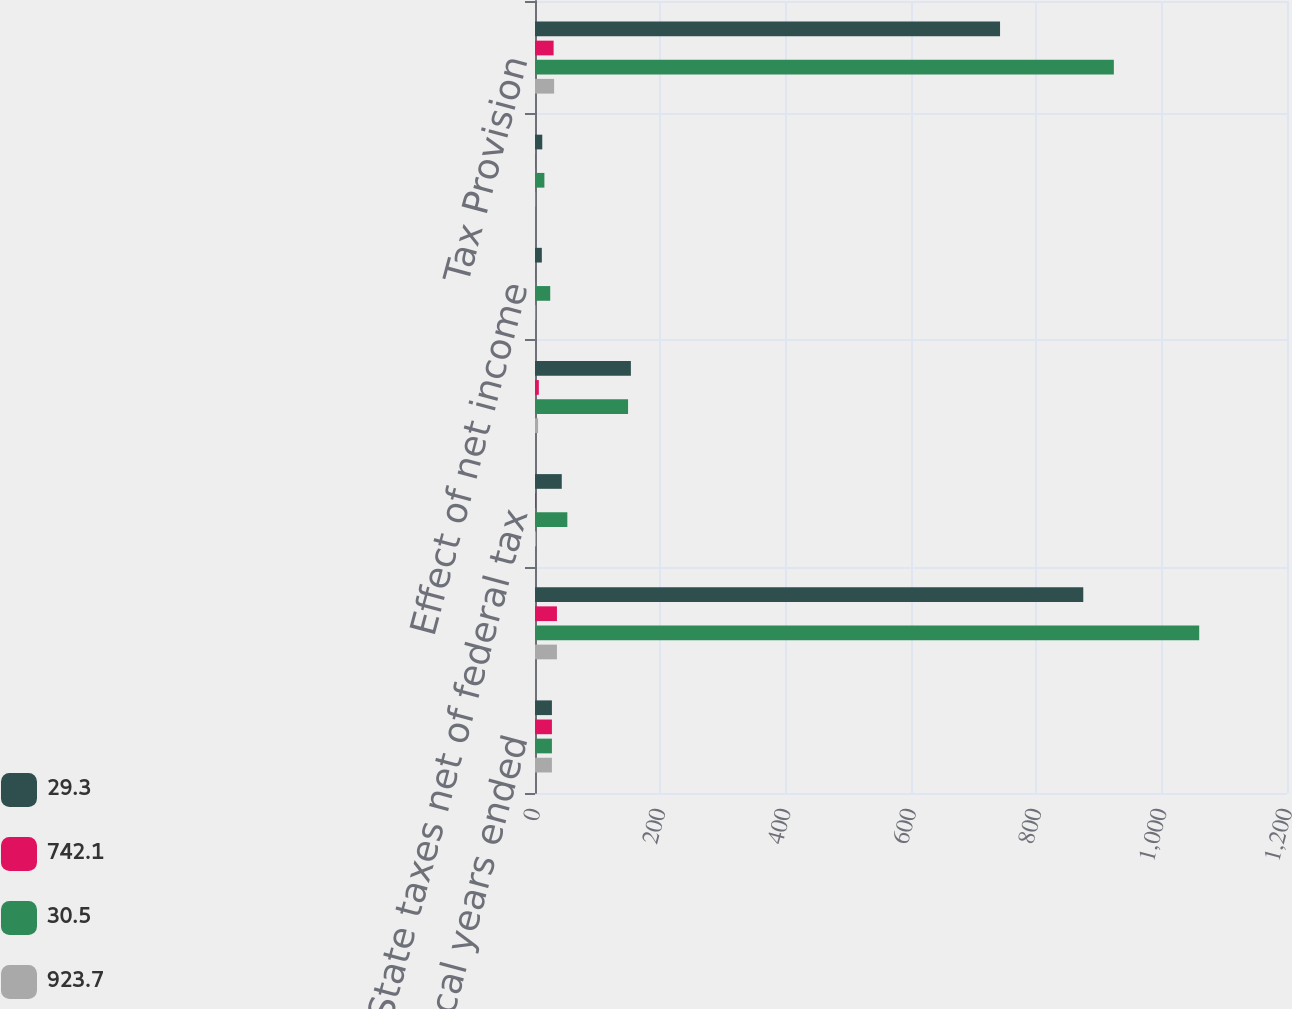Convert chart to OTSL. <chart><loc_0><loc_0><loc_500><loc_500><stacked_bar_chart><ecel><fcel>for the fiscal years ended<fcel>Federal taxes at statutory<fcel>State taxes net of federal tax<fcel>Effect of non-US operations<fcel>Effect of net income<fcel>Other<fcel>Tax Provision<nl><fcel>29.3<fcel>27<fcel>874.9<fcel>42.7<fcel>153<fcel>10.9<fcel>11.6<fcel>742.1<nl><fcel>742.1<fcel>27<fcel>35<fcel>1.7<fcel>6.1<fcel>0.4<fcel>0.5<fcel>29.7<nl><fcel>30.5<fcel>27<fcel>1059.9<fcel>51.6<fcel>148.5<fcel>24.3<fcel>15<fcel>923.7<nl><fcel>923.7<fcel>27<fcel>35<fcel>1.7<fcel>4.9<fcel>0.8<fcel>0.5<fcel>30.5<nl></chart> 